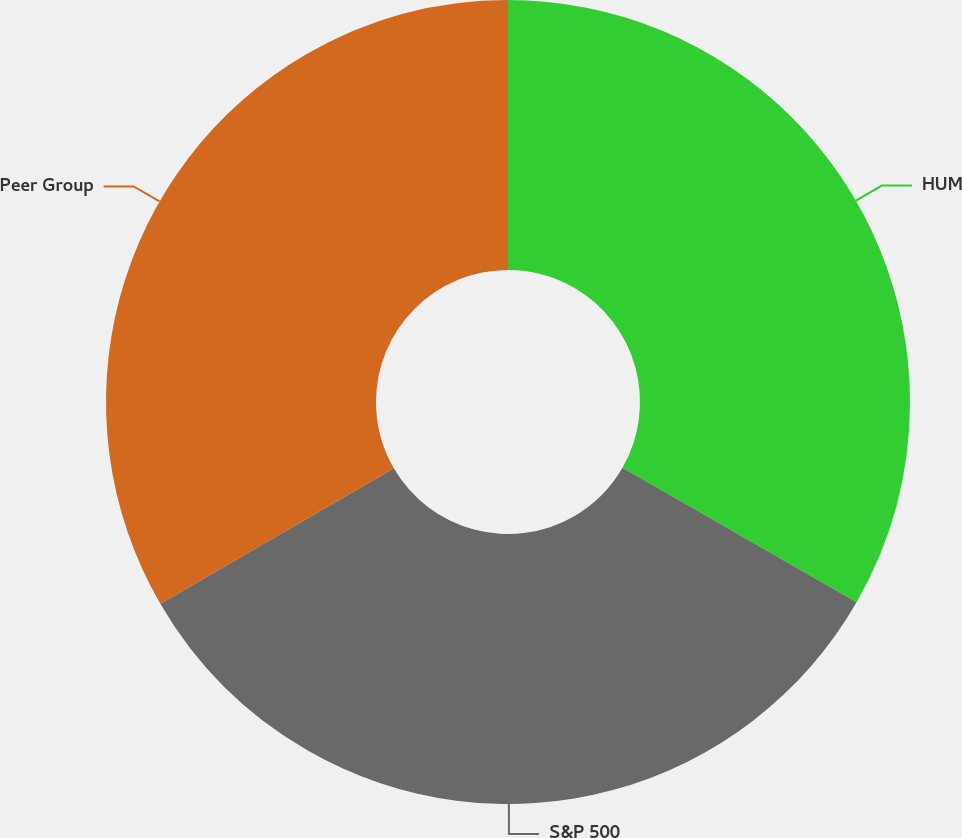Convert chart to OTSL. <chart><loc_0><loc_0><loc_500><loc_500><pie_chart><fcel>HUM<fcel>S&P 500<fcel>Peer Group<nl><fcel>33.3%<fcel>33.33%<fcel>33.37%<nl></chart> 